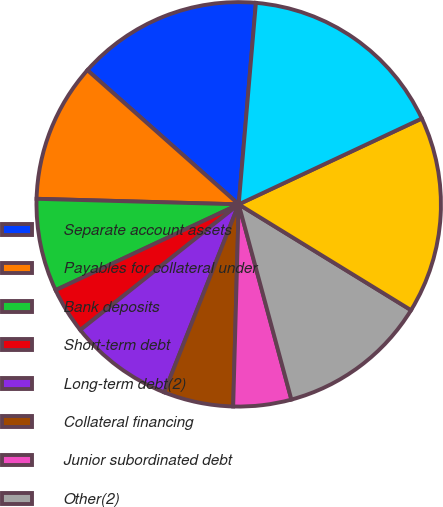<chart> <loc_0><loc_0><loc_500><loc_500><pie_chart><fcel>Separate account assets<fcel>Payables for collateral under<fcel>Bank deposits<fcel>Short-term debt<fcel>Long-term debt(2)<fcel>Collateral financing<fcel>Junior subordinated debt<fcel>Other(2)<fcel>Separate account liabilities<fcel>Total liabilities<nl><fcel>14.81%<fcel>11.11%<fcel>7.41%<fcel>3.7%<fcel>8.33%<fcel>5.56%<fcel>4.63%<fcel>12.04%<fcel>15.74%<fcel>16.67%<nl></chart> 